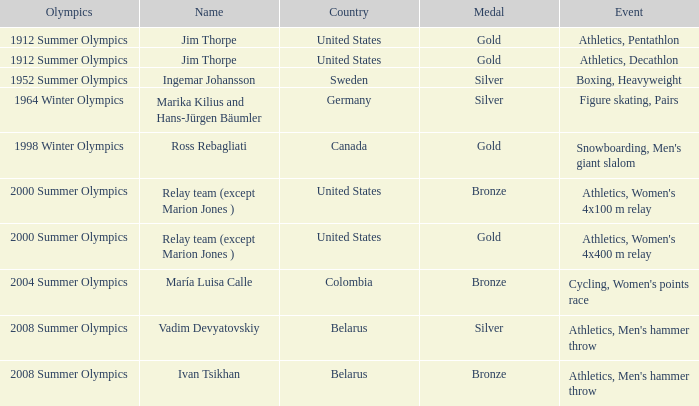In the 2000 summer olympics, which event involved a bronze medal? Athletics, Women's 4x100 m relay. 